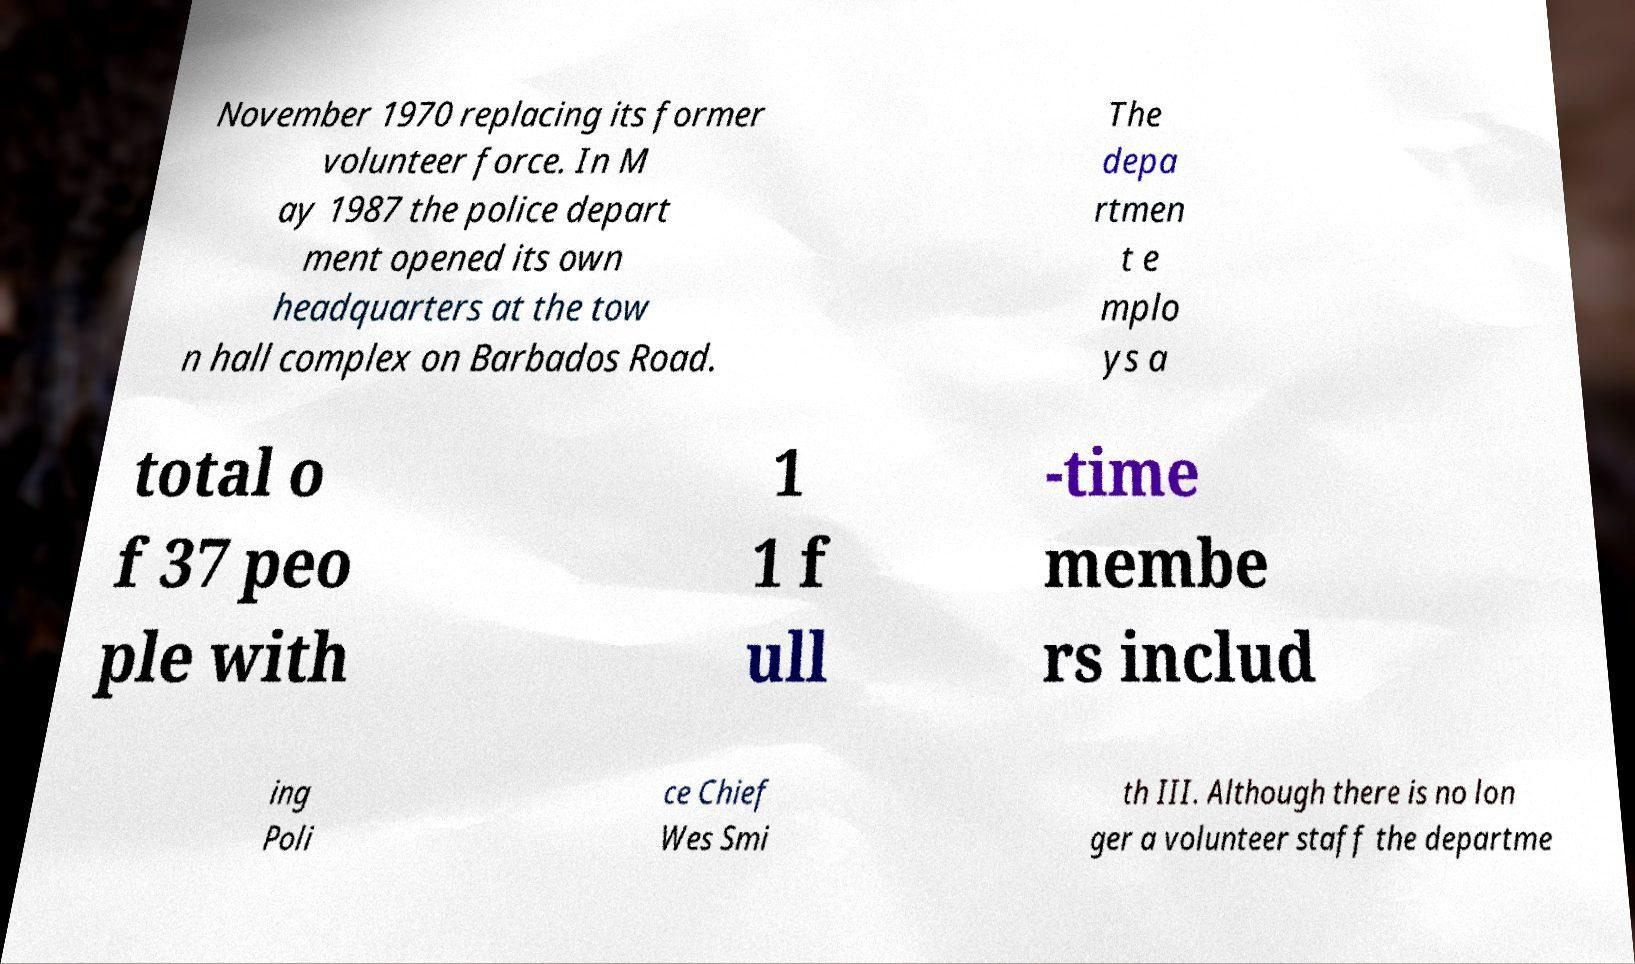Could you assist in decoding the text presented in this image and type it out clearly? November 1970 replacing its former volunteer force. In M ay 1987 the police depart ment opened its own headquarters at the tow n hall complex on Barbados Road. The depa rtmen t e mplo ys a total o f 37 peo ple with 1 1 f ull -time membe rs includ ing Poli ce Chief Wes Smi th III. Although there is no lon ger a volunteer staff the departme 